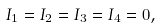<formula> <loc_0><loc_0><loc_500><loc_500>I _ { 1 } = I _ { 2 } = I _ { 3 } = I _ { 4 } = 0 ,</formula> 